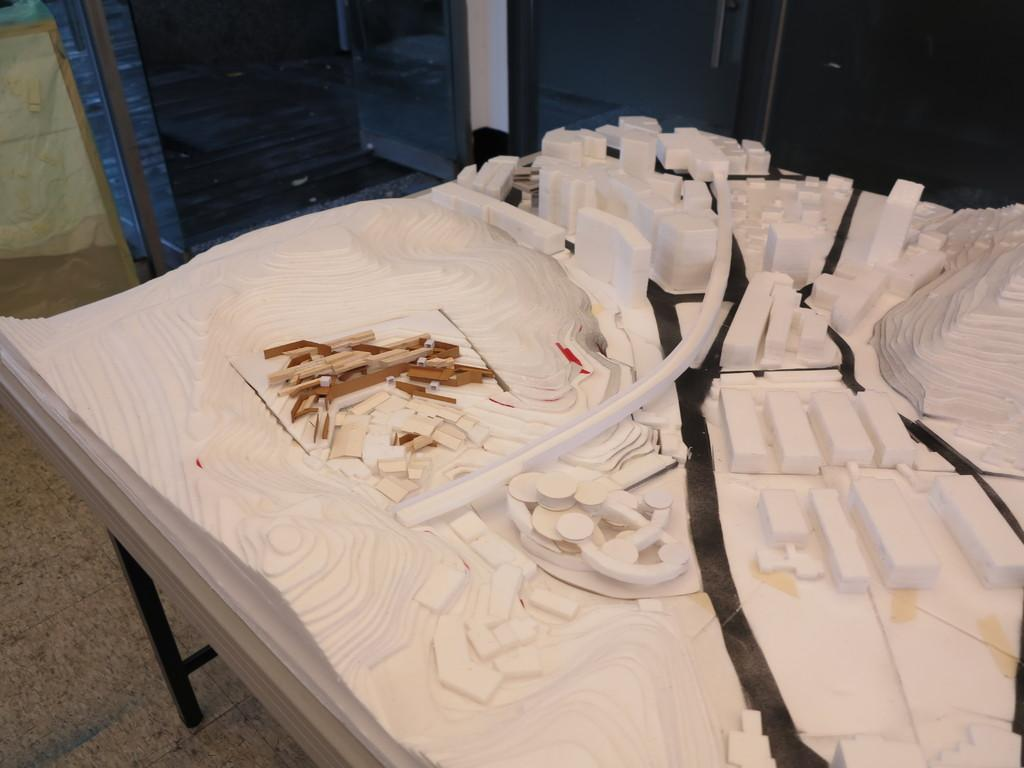What type of structure can be seen in the image? There is a wall in the image. What type of furniture is present in the image? There is a wooden table in the image. How many eyes can be seen on the wooden table in the image? There are no eyes present on the wooden table in the image. What type of waves can be seen in the image? There are no waves present in the image. 